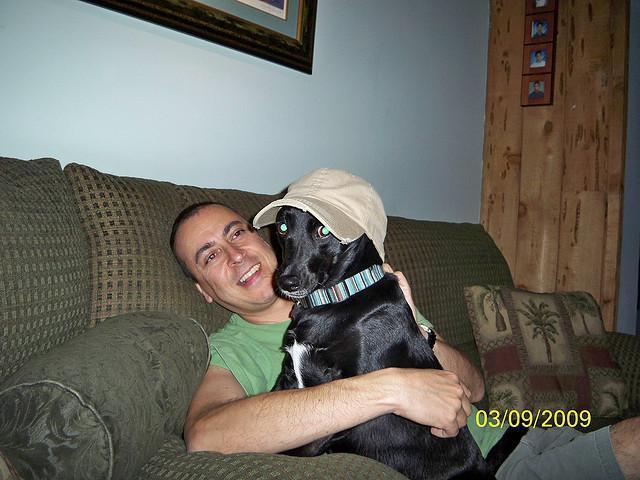Is the given caption "The person is at the left side of the couch." fitting for the image?
Answer yes or no. No. 